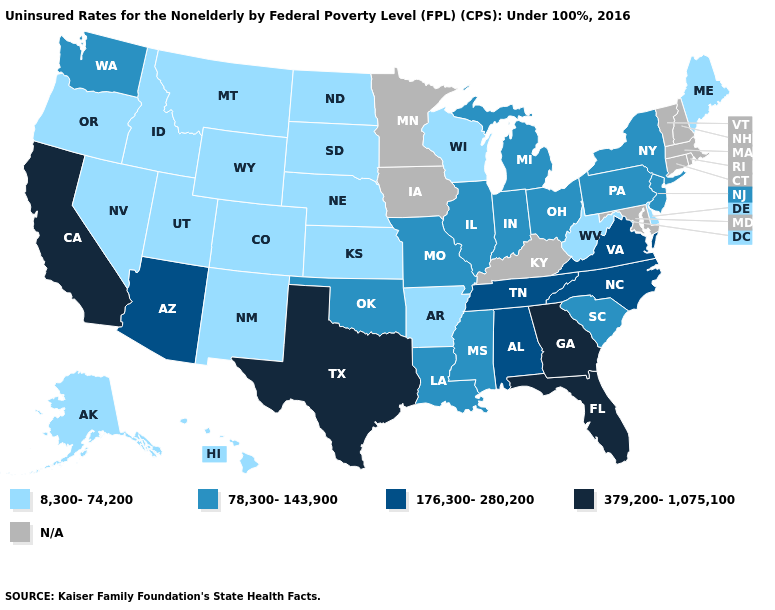Name the states that have a value in the range 379,200-1,075,100?
Quick response, please. California, Florida, Georgia, Texas. Which states have the highest value in the USA?
Write a very short answer. California, Florida, Georgia, Texas. Does the first symbol in the legend represent the smallest category?
Give a very brief answer. Yes. What is the value of Maine?
Quick response, please. 8,300-74,200. What is the value of Nevada?
Quick response, please. 8,300-74,200. Name the states that have a value in the range 176,300-280,200?
Answer briefly. Alabama, Arizona, North Carolina, Tennessee, Virginia. What is the value of Utah?
Concise answer only. 8,300-74,200. What is the value of Oklahoma?
Write a very short answer. 78,300-143,900. Name the states that have a value in the range 176,300-280,200?
Keep it brief. Alabama, Arizona, North Carolina, Tennessee, Virginia. Which states have the highest value in the USA?
Answer briefly. California, Florida, Georgia, Texas. What is the value of Louisiana?
Quick response, please. 78,300-143,900. What is the value of Massachusetts?
Quick response, please. N/A. 